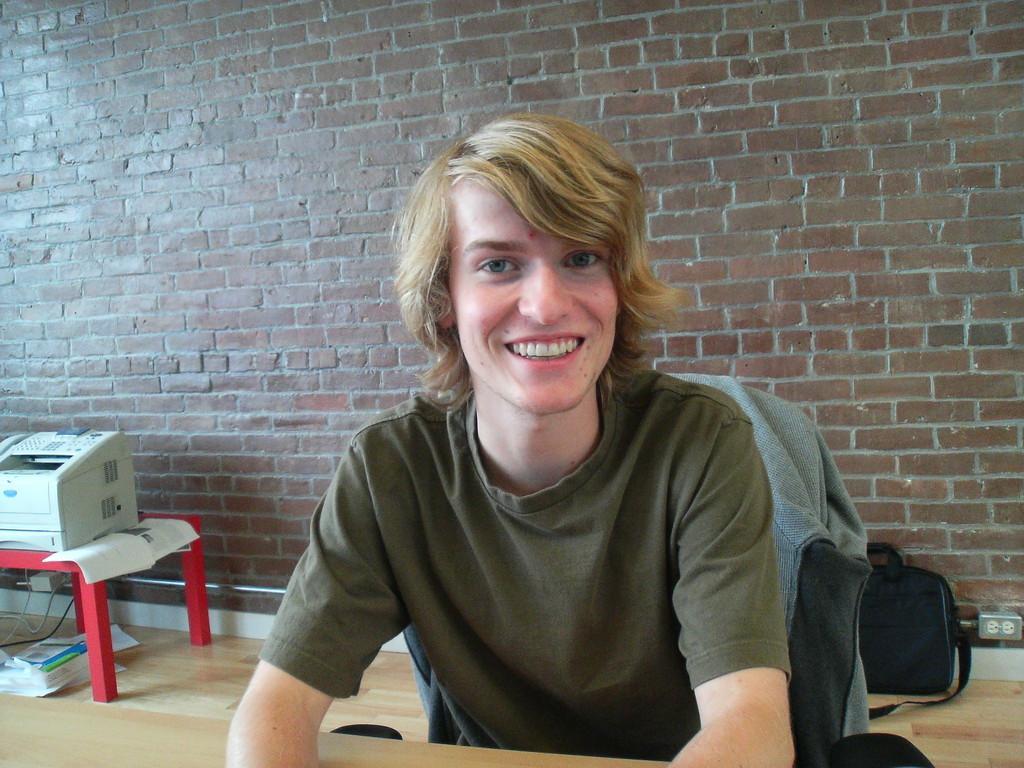Can you describe this image briefly? In the center of the image there is a person sitting on a chair he is smiling. On the left there is a table. There is a printer and some papers placed on the table. In the background there is a brick wall. 